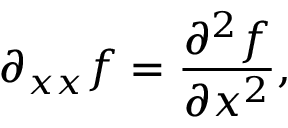<formula> <loc_0><loc_0><loc_500><loc_500>\partial _ { x x } f = { \frac { \partial ^ { 2 } f } { \partial x ^ { 2 } } } ,</formula> 